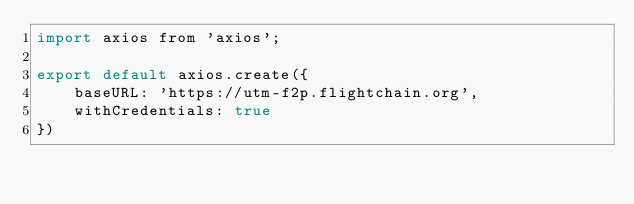<code> <loc_0><loc_0><loc_500><loc_500><_JavaScript_>import axios from 'axios';

export default axios.create({
    baseURL: 'https://utm-f2p.flightchain.org',
    withCredentials: true
})</code> 